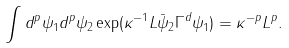Convert formula to latex. <formula><loc_0><loc_0><loc_500><loc_500>\int d ^ { p } \psi _ { 1 } d ^ { p } \psi _ { 2 } \exp ( \kappa ^ { - 1 } L \bar { \psi } _ { 2 } \Gamma ^ { d } \psi _ { 1 } ) = \kappa ^ { - p } L ^ { p } .</formula> 